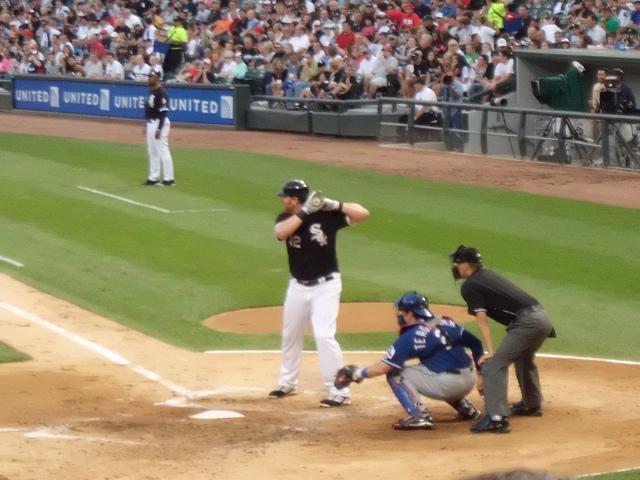Has the batter hit the ball yet?
Quick response, please. No. Are other players watching?
Be succinct. Yes. What is on the banner in white and blue?
Short answer required. United. Why is the middle man crouching?
Concise answer only. Catcher. 